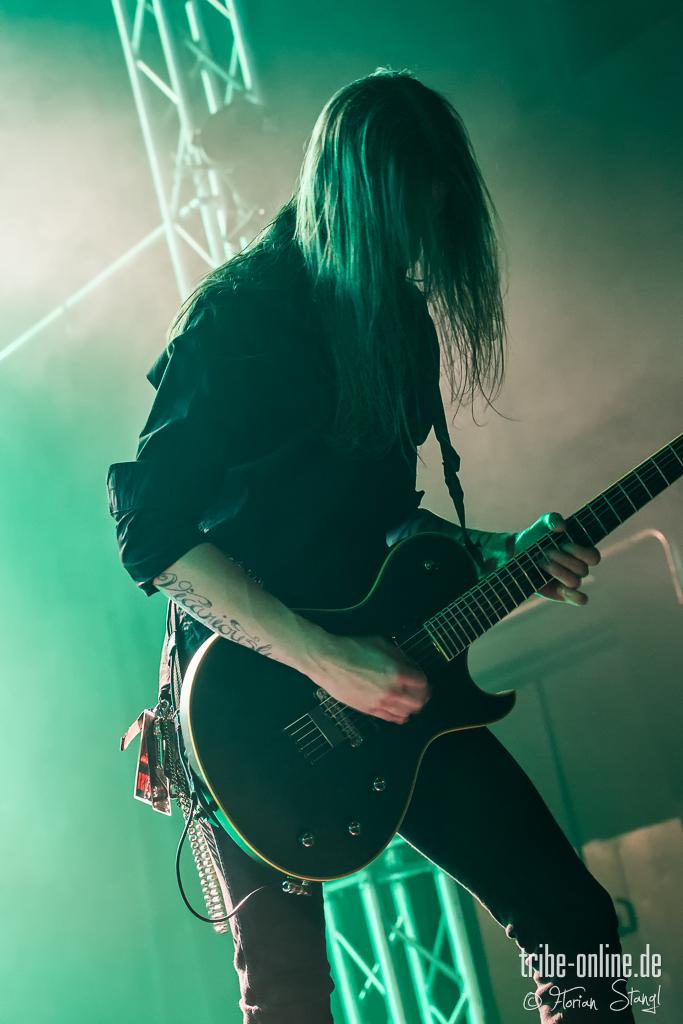What is the main activity being performed by the person in the image? There is a person playing a guitar in the image. What can be seen in the background of the image? There is a stand with rods in the background of the image. Where is the text located in the image? The text is in the right bottom corner of the image. Can you see a group of rats playing musical instruments with the person in the image? No, there are no rats or additional musicians present in the image; it only features a person playing a guitar. Is there an airplane visible in the image? No, there is no airplane present in the image. 